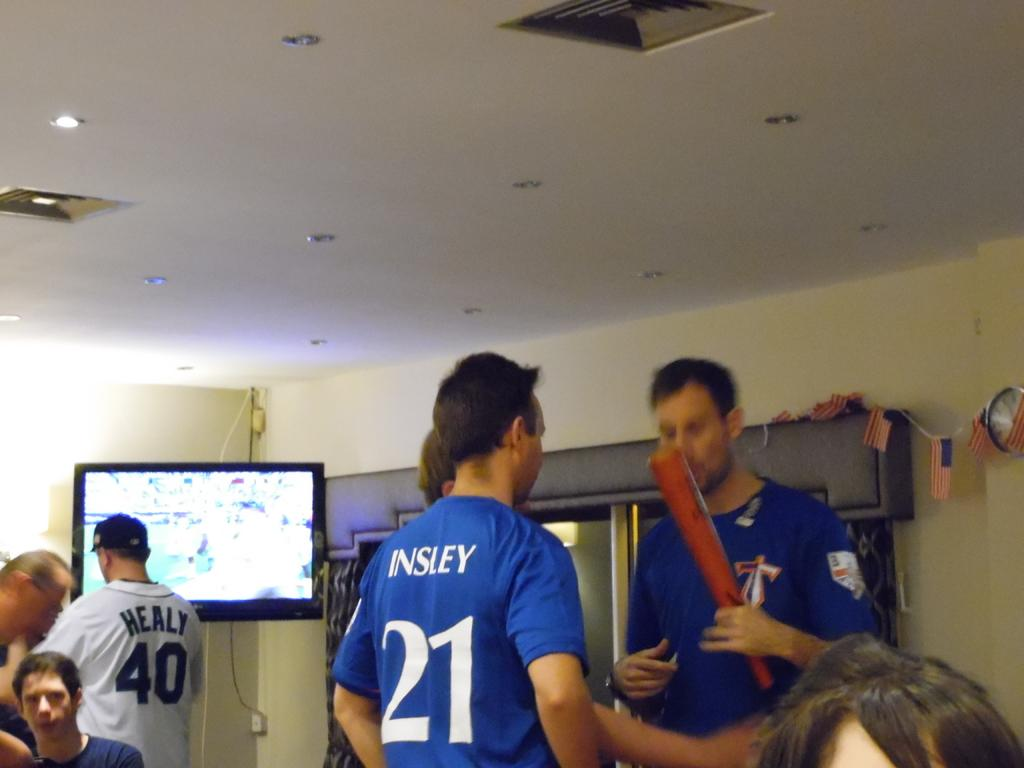<image>
Render a clear and concise summary of the photo. A man in a Insley sports jersey conversing with another man. 